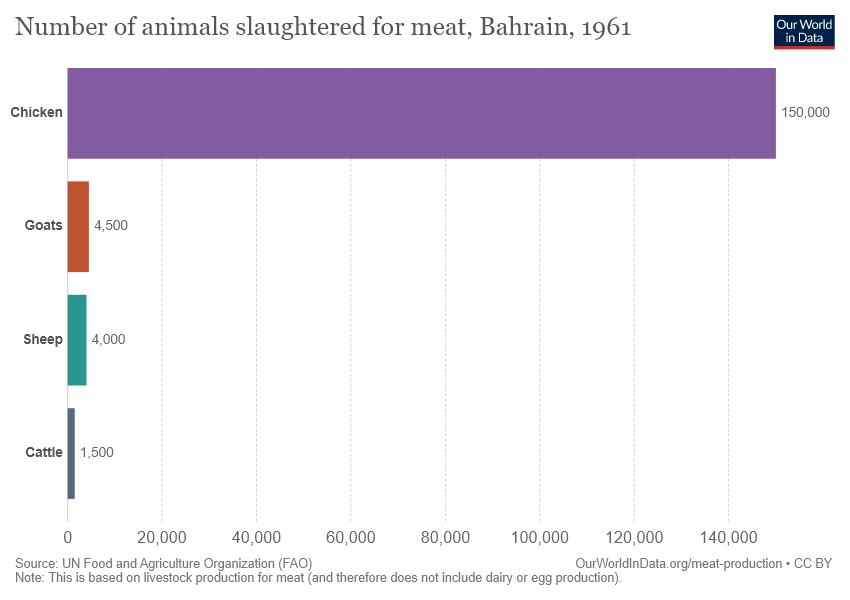Mention a couple of crucial points in this snapshot. The animal that is represented by the smallest bar is cattle. The average of Sheep and Goats is 4250. 